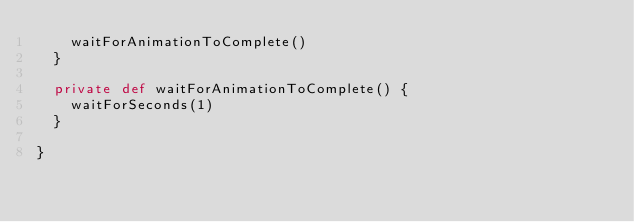Convert code to text. <code><loc_0><loc_0><loc_500><loc_500><_Scala_>    waitForAnimationToComplete()
  }

  private def waitForAnimationToComplete() {
    waitForSeconds(1)
  }

}
</code> 